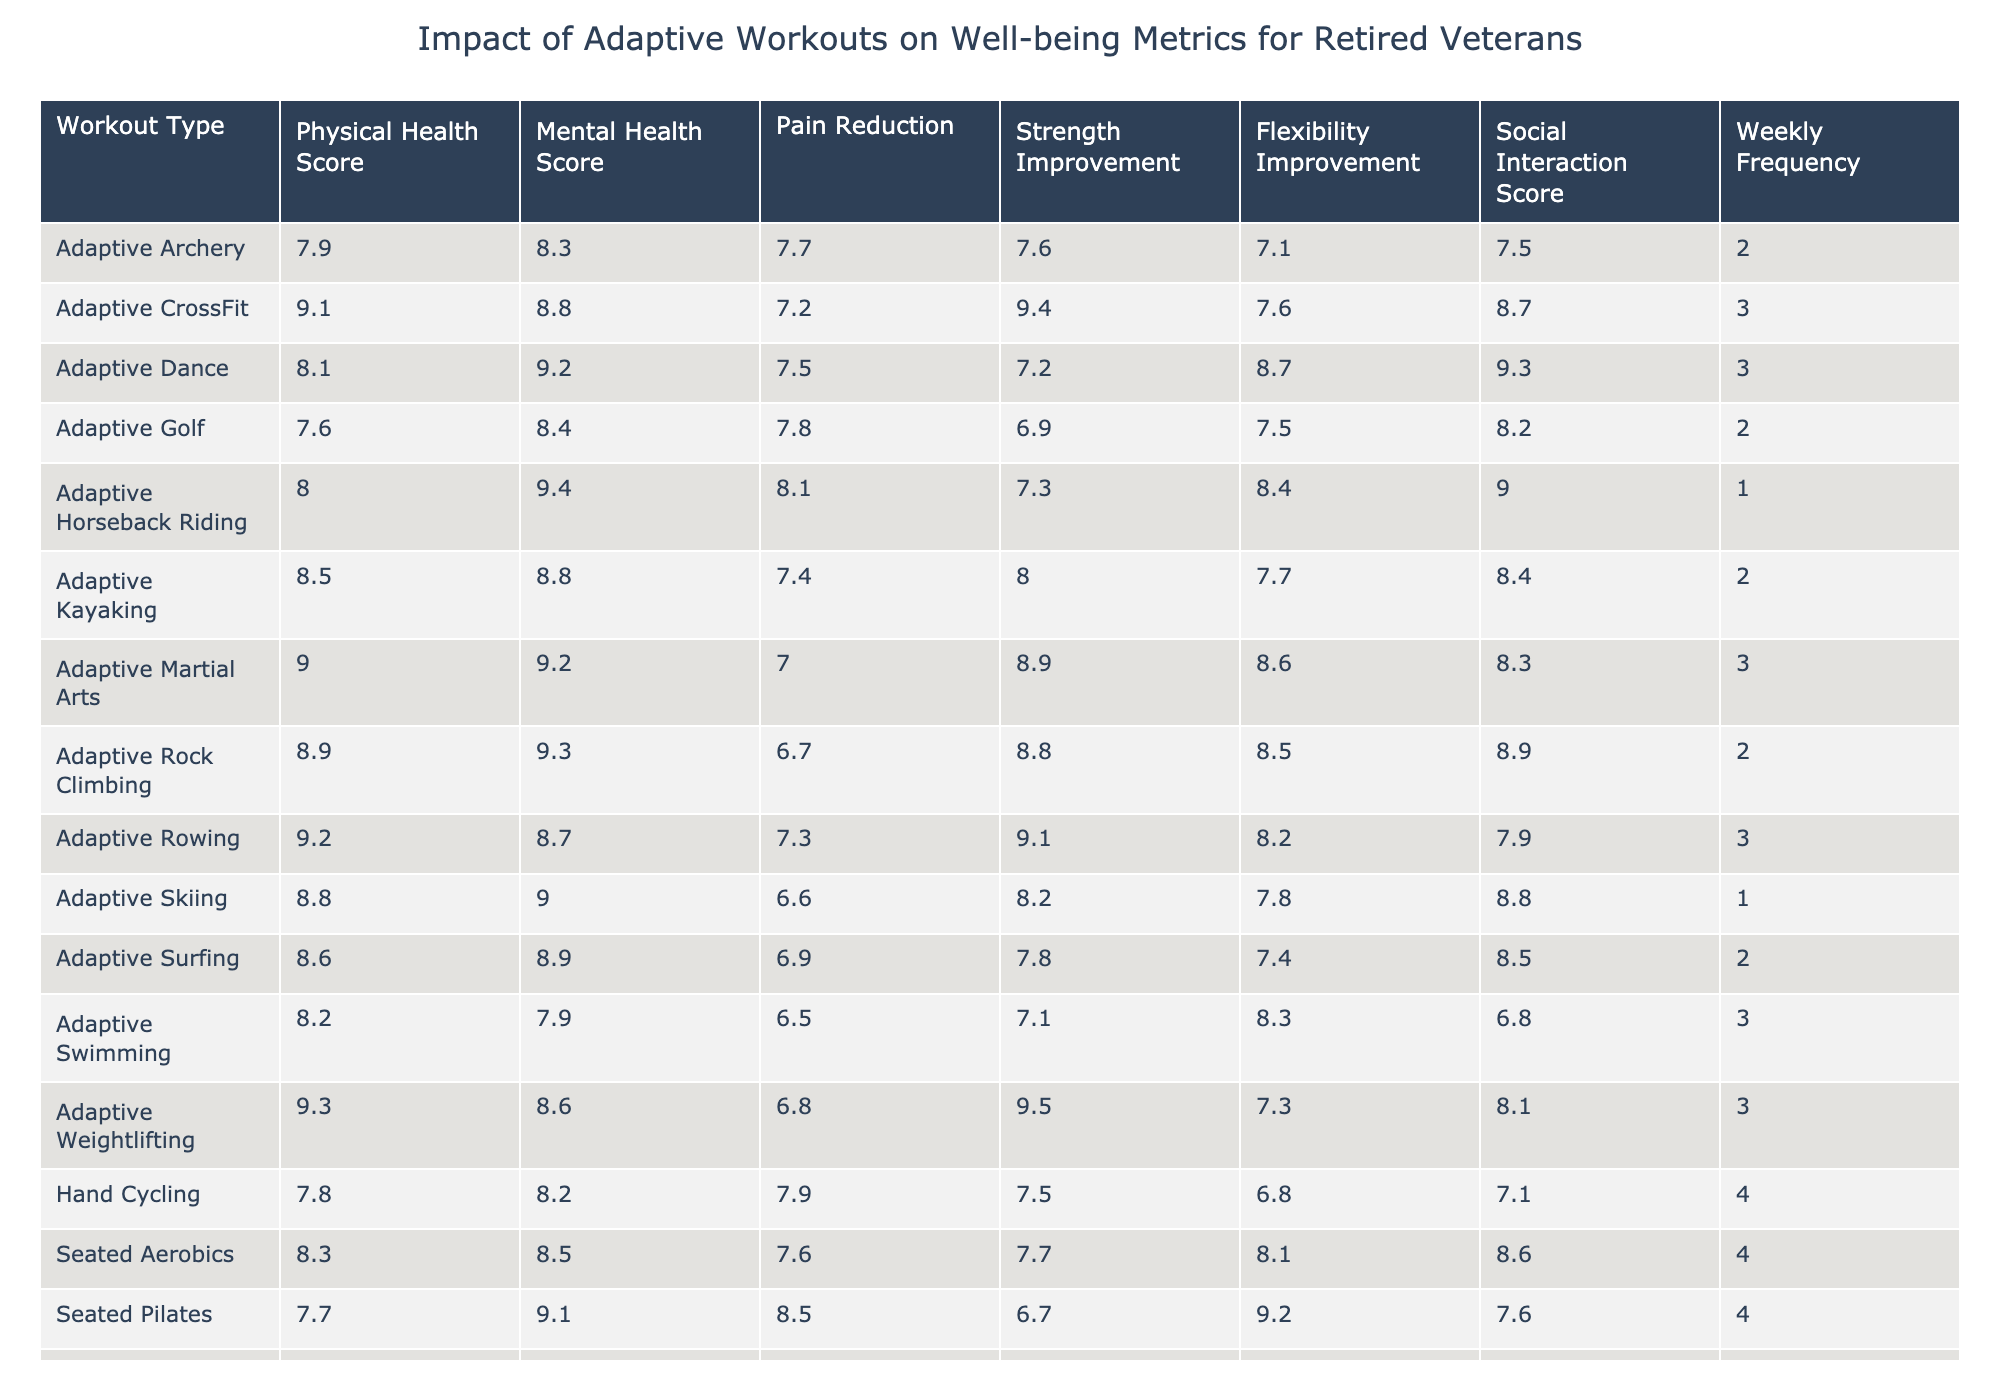What is the highest physical health score among the adaptive workout types? By examining the table, we look for the maximum value in the Physical Health Score column. The values are 8.2, 7.5, 8.7, 9.1, 7.8, 8.9, 7.3, 8.1, 8.6, 8.4, 8.3, 8.8, 9.2, 7.9, 9.3, 7.7, 8.5, 8.0, 9.0. The highest score is 9.3 corresponding to Adaptive Weightlifting.
Answer: 9.3 What is the average mental health score for Adaptive Dancing and Seated Yoga? First, we find the mental health scores for the specified workouts: Adaptive Dance has a score of 9.2 and Seated Yoga has a score of 8.6. To calculate the average, we sum the two scores (9.2 + 8.6 = 17.8), and divide by the number of workouts (2). Therefore, the average mental health score is 17.8 / 2 = 8.9.
Answer: 8.9 Is the average pain reduction for Adaptive Swimming greater than that for Wheelchair Basketball? We first look at the Pain Reduction scores: Adaptive Swimming has a score of 6.5, and Wheelchair Basketball has a score of 5.8. Since 6.5 is greater than 5.8, we conclude that the average pain reduction for Adaptive Swimming is indeed greater.
Answer: Yes What is the combined total strength improvement score for Adaptive Rowing and Adaptive CrossFit? We check the Strength Improvement scores: Adaptive Rowing has a score of 9.1, and Adaptive CrossFit has a score of 9.4. We then sum these two values (9.1 + 9.4 = 18.5) to find the combined total strength improvement score for both workouts.
Answer: 18.5 What is the most commonly attended adaptive workout type based on weekly frequency? To determine the most commonly attended workout type, we compare the Weekly Frequency scores. The maximum average value is 4, which is observed in Seated Yoga, Hand Cycling, Seated Aerobics, and Wheelchair Tennis. Since these workouts are all equal, we identify them as being the most commonly attended.
Answer: Seated Yoga, Hand Cycling, Seated Aerobics, Wheelchair Tennis What is the difference in social interaction scores between Adaptive Surfing and Seated Tai Chi? Looking at the Social Interaction Scores, Adaptive Surfing has 8.5 and Seated Tai Chi has 7.8. To find the difference, we subtract Seated Tai Chi's score from Adaptive Surfing's score (8.5 - 7.8 = 0.7), indicating that Adaptive Surfing has a higher social interaction score than Seated Tai Chi by 0.7.
Answer: 0.7 Does Seated Pilates have a higher physical health score than Adaptive Golf? The Physical Health Score for Seated Pilates is 7.7, while Adaptive Golf is at 7.6. Since 7.7 is greater than 7.6, we determine that Seated Pilates does indeed have a higher physical health score than Adaptive Golf.
Answer: Yes Which workout type has the lowest score in flexibility improvement? By reviewing the Flexibility Improvement scores, we find that Adaptive Golf has a score of 7.5, which is the lowest when compared to other workout types. Therefore, Adaptive Golf is identified as the workout with the lowest flexibility improvement score.
Answer: Adaptive Golf 